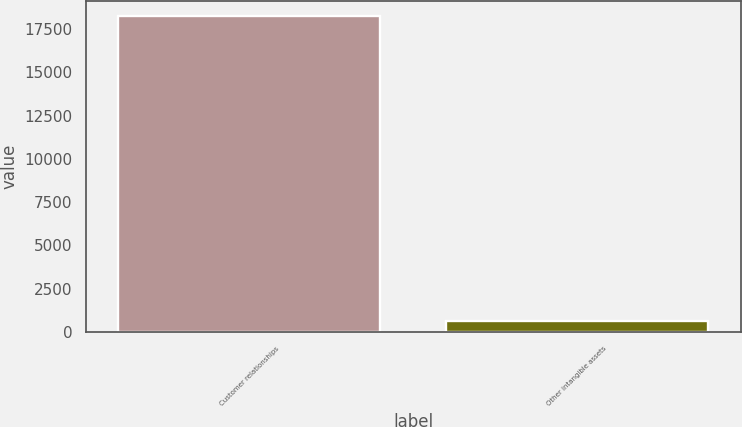Convert chart. <chart><loc_0><loc_0><loc_500><loc_500><bar_chart><fcel>Customer relationships<fcel>Other intangible assets<nl><fcel>18226<fcel>615<nl></chart> 